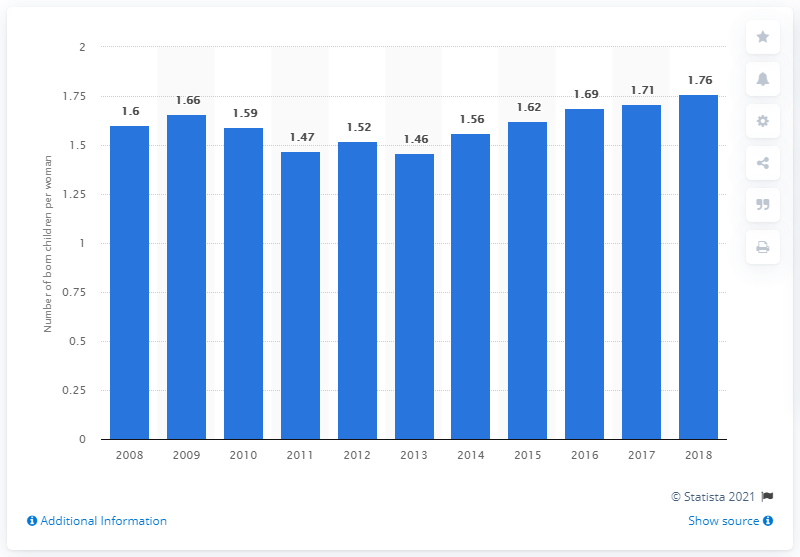Point out several critical features in this image. In 2018, the fertility rate in Romania was 1.76. 